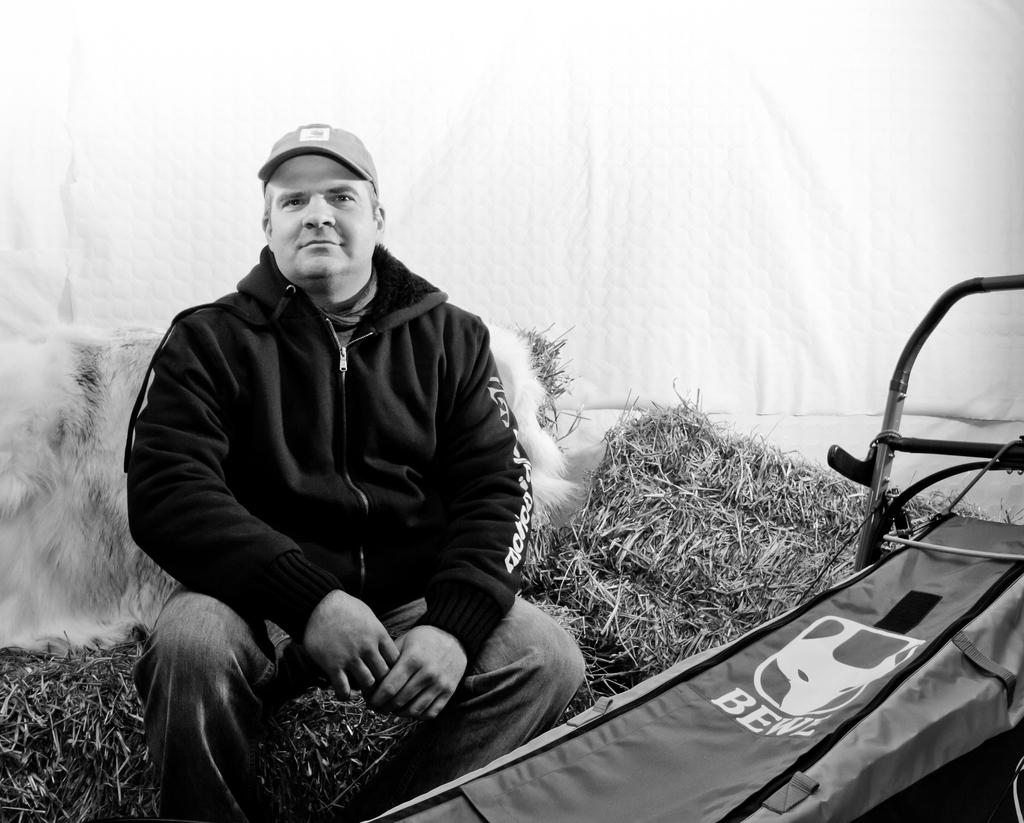What is the main subject of the picture? The main subject of the picture is a person. What can be observed about the person's attire? The person is wearing a cap. What is the person's position in the image? The person is sitting on a surface. What type of answer can be seen written on the chair in the image? There is no chair or written answer present in the image. 